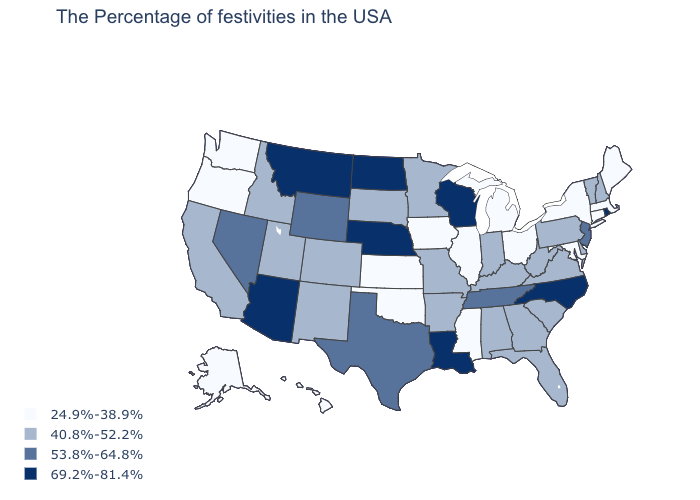Among the states that border Massachusetts , which have the lowest value?
Short answer required. Connecticut, New York. Among the states that border Nebraska , does Wyoming have the highest value?
Answer briefly. Yes. Is the legend a continuous bar?
Keep it brief. No. What is the highest value in the South ?
Answer briefly. 69.2%-81.4%. What is the value of Georgia?
Give a very brief answer. 40.8%-52.2%. Which states have the lowest value in the USA?
Write a very short answer. Maine, Massachusetts, Connecticut, New York, Maryland, Ohio, Michigan, Illinois, Mississippi, Iowa, Kansas, Oklahoma, Washington, Oregon, Alaska, Hawaii. Which states have the lowest value in the MidWest?
Give a very brief answer. Ohio, Michigan, Illinois, Iowa, Kansas. Does the first symbol in the legend represent the smallest category?
Answer briefly. Yes. Name the states that have a value in the range 69.2%-81.4%?
Quick response, please. Rhode Island, North Carolina, Wisconsin, Louisiana, Nebraska, North Dakota, Montana, Arizona. Does Mississippi have the same value as Oklahoma?
Answer briefly. Yes. What is the value of Washington?
Keep it brief. 24.9%-38.9%. What is the value of Michigan?
Quick response, please. 24.9%-38.9%. What is the value of Indiana?
Write a very short answer. 40.8%-52.2%. Name the states that have a value in the range 53.8%-64.8%?
Answer briefly. New Jersey, Tennessee, Texas, Wyoming, Nevada. 